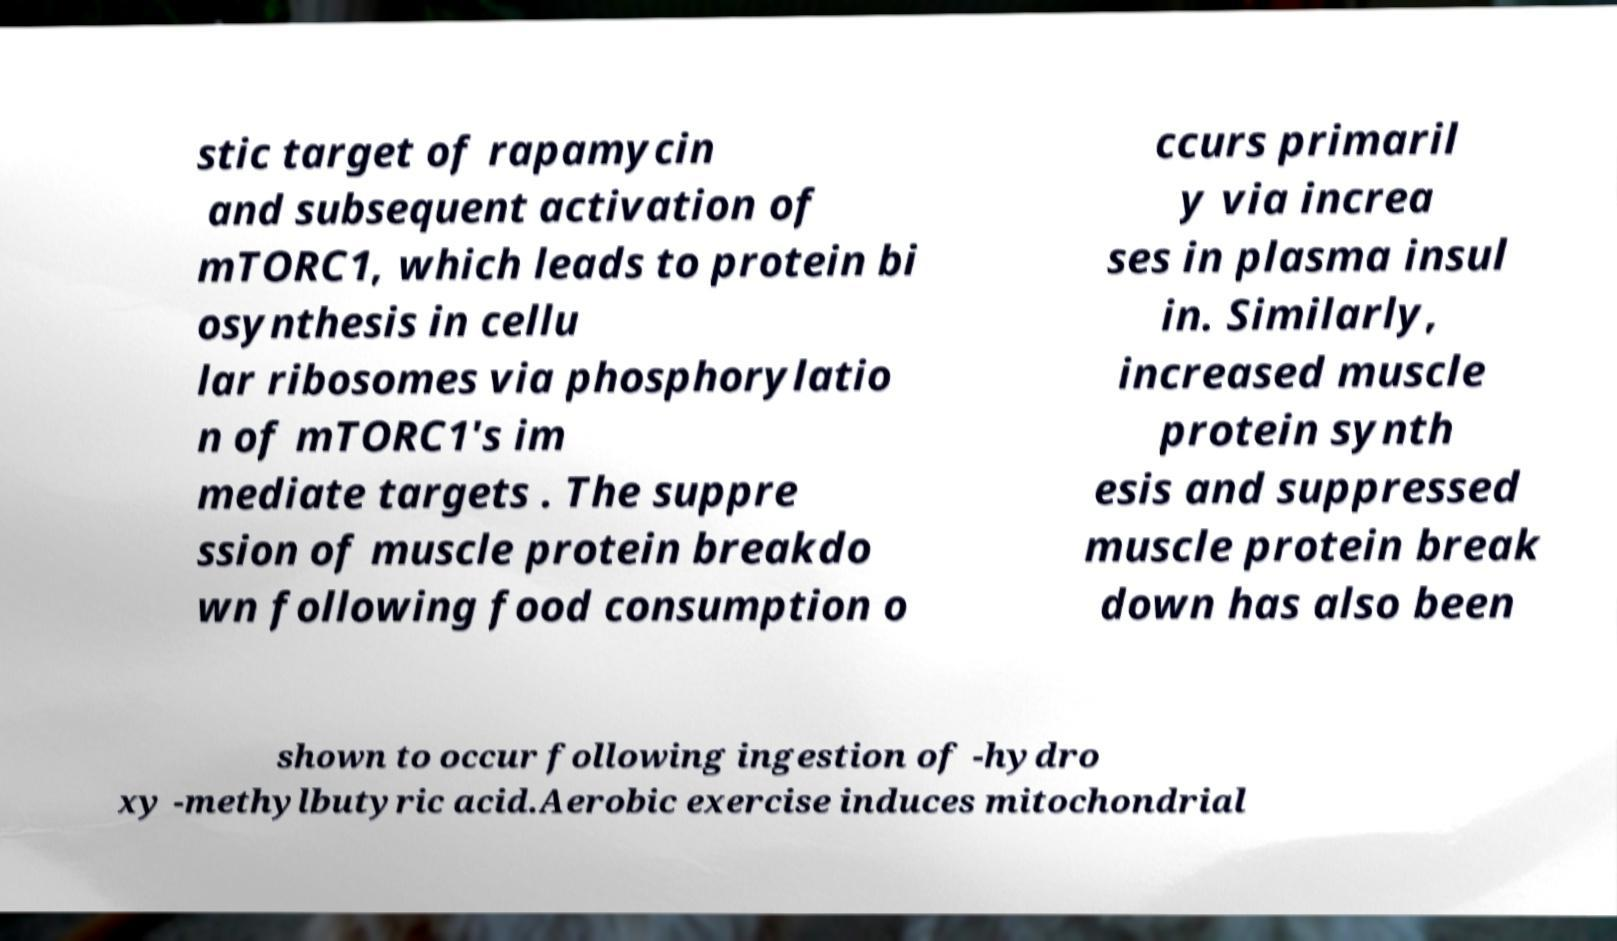I need the written content from this picture converted into text. Can you do that? stic target of rapamycin and subsequent activation of mTORC1, which leads to protein bi osynthesis in cellu lar ribosomes via phosphorylatio n of mTORC1's im mediate targets . The suppre ssion of muscle protein breakdo wn following food consumption o ccurs primaril y via increa ses in plasma insul in. Similarly, increased muscle protein synth esis and suppressed muscle protein break down has also been shown to occur following ingestion of -hydro xy -methylbutyric acid.Aerobic exercise induces mitochondrial 